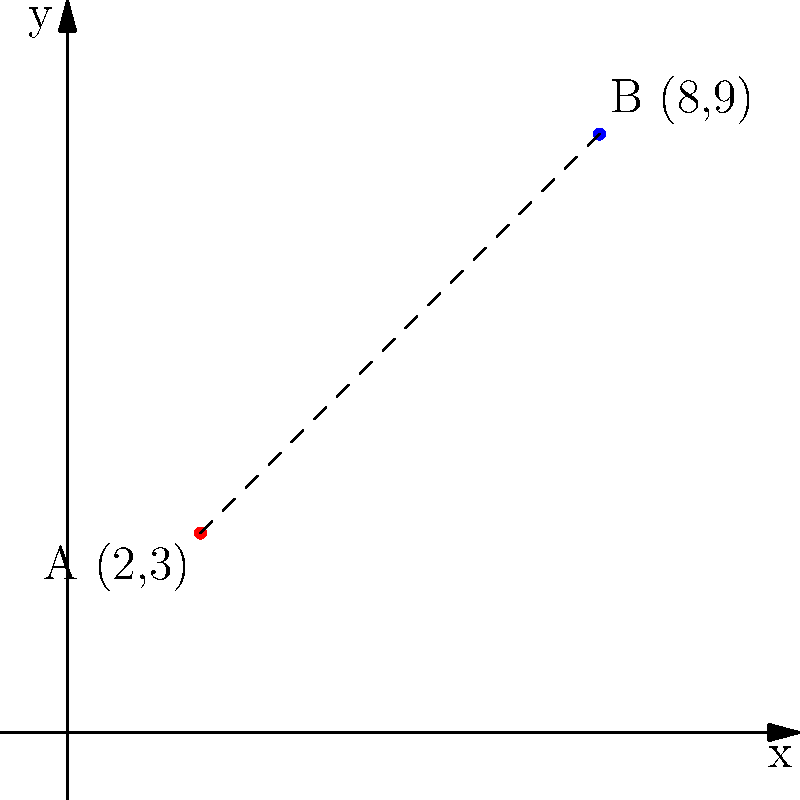On a campus map represented by a coordinate system, two school buildings are located at points A(2,3) and B(8,9). Calculate the distance between these two buildings to determine the most efficient path for students and promote physical activity. Round your answer to two decimal places. To calculate the distance between two points in a coordinate system, we can use the distance formula, which is derived from the Pythagorean theorem:

1. The distance formula is:
   $$d = \sqrt{(x_2 - x_1)^2 + (y_2 - y_1)^2}$$

2. Identify the coordinates:
   Point A: $(x_1, y_1) = (2, 3)$
   Point B: $(x_2, y_2) = (8, 9)$

3. Substitute the values into the formula:
   $$d = \sqrt{(8 - 2)^2 + (9 - 3)^2}$$

4. Simplify:
   $$d = \sqrt{6^2 + 6^2}$$
   $$d = \sqrt{36 + 36}$$
   $$d = \sqrt{72}$$

5. Calculate the square root:
   $$d \approx 8.4852813742$$

6. Round to two decimal places:
   $$d \approx 8.49$$

Therefore, the distance between the two school buildings is approximately 8.49 units on the campus map.
Answer: 8.49 units 